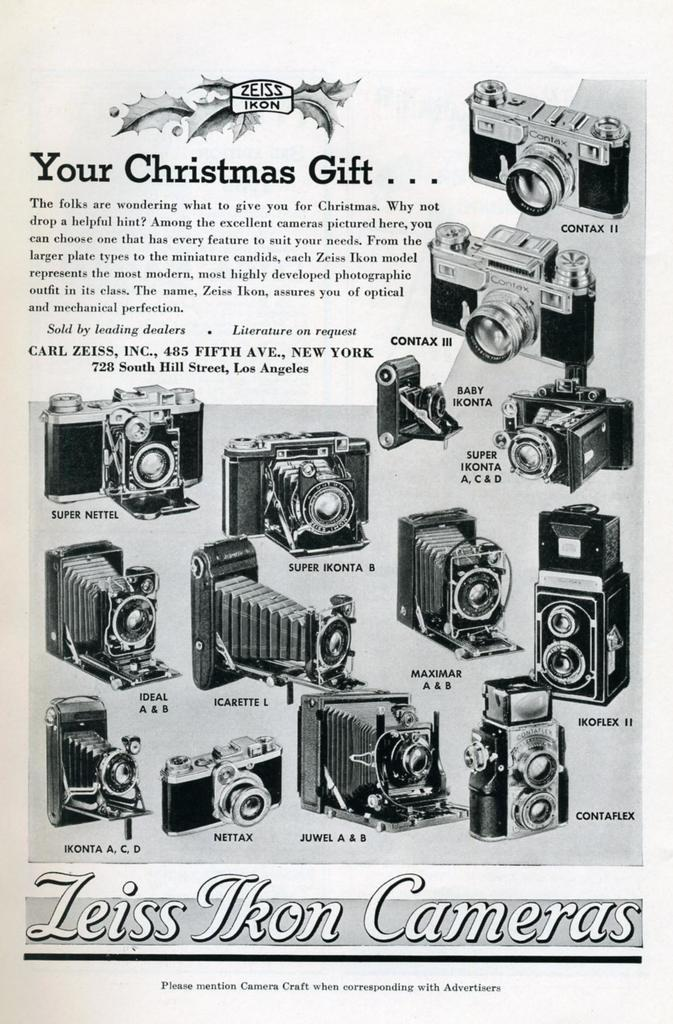What objects are present in the picture? There are cameras in the picture. Can you describe the cameras in the picture? The cameras are of different types. What can be seen above and below the cameras? There is something written above and below the cameras. How many cats are present in the picture? There are no cats present in the picture; it features cameras of different types. What type of self-defense training are the cameras undergoing in the picture? The cameras are not undergoing any self-defense training; they are inanimate objects in the picture. 